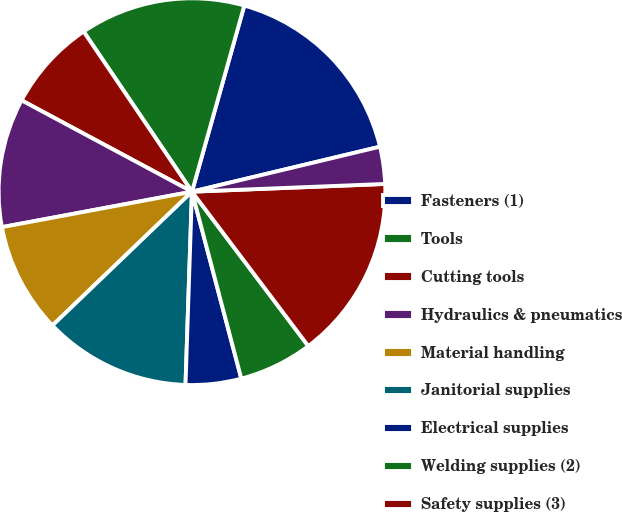<chart> <loc_0><loc_0><loc_500><loc_500><pie_chart><fcel>Fasteners (1)<fcel>Tools<fcel>Cutting tools<fcel>Hydraulics & pneumatics<fcel>Material handling<fcel>Janitorial supplies<fcel>Electrical supplies<fcel>Welding supplies (2)<fcel>Safety supplies (3)<fcel>Metals<nl><fcel>16.9%<fcel>13.83%<fcel>7.7%<fcel>10.77%<fcel>9.23%<fcel>12.3%<fcel>4.64%<fcel>6.17%<fcel>15.36%<fcel>3.1%<nl></chart> 